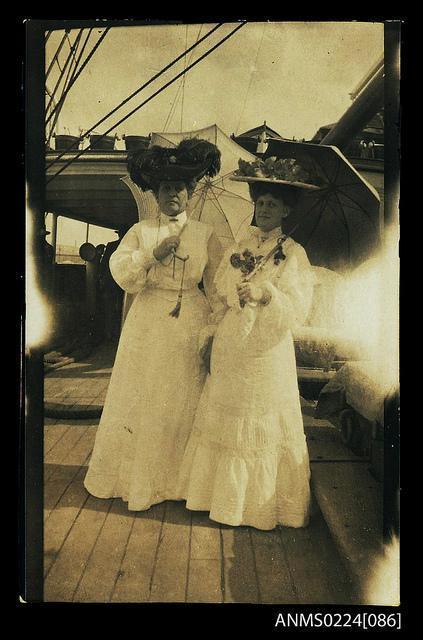How many people are wearing hats in this photo?
Give a very brief answer. 2. How many umbrellas are in the picture?
Give a very brief answer. 2. How many people are there?
Give a very brief answer. 2. 